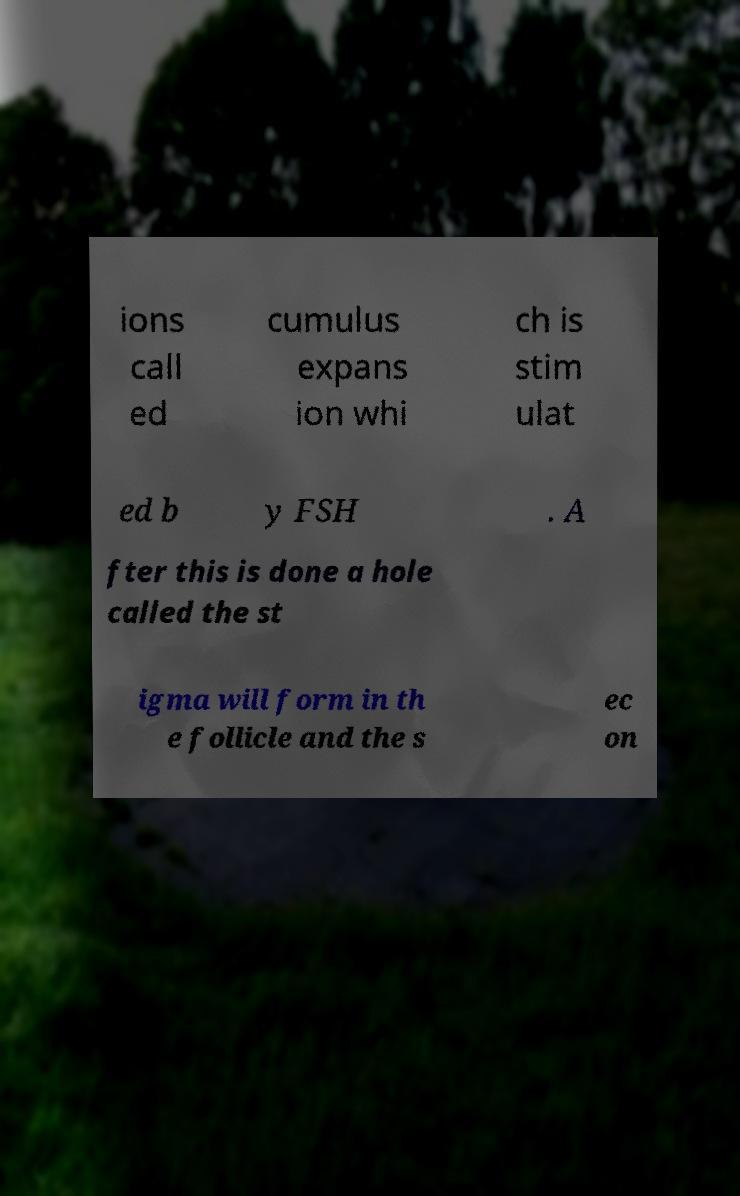Can you read and provide the text displayed in the image?This photo seems to have some interesting text. Can you extract and type it out for me? ions call ed cumulus expans ion whi ch is stim ulat ed b y FSH . A fter this is done a hole called the st igma will form in th e follicle and the s ec on 